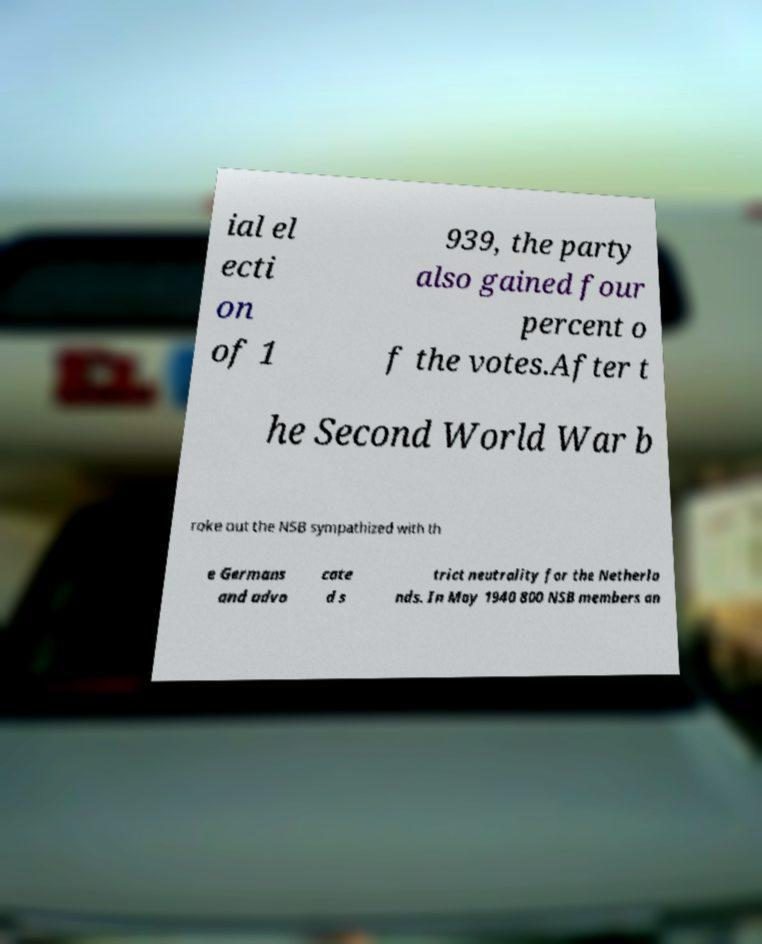For documentation purposes, I need the text within this image transcribed. Could you provide that? ial el ecti on of 1 939, the party also gained four percent o f the votes.After t he Second World War b roke out the NSB sympathized with th e Germans and advo cate d s trict neutrality for the Netherla nds. In May 1940 800 NSB members an 